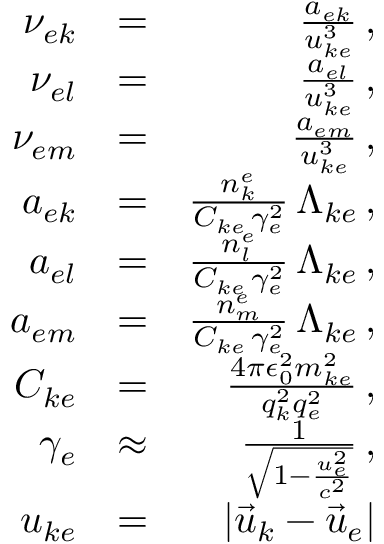Convert formula to latex. <formula><loc_0><loc_0><loc_500><loc_500>\begin{array} { r l r } { \nu _ { e k } } & { = } & { \frac { a _ { e k } } { u _ { k e } ^ { 3 } } \, , } \\ { \nu _ { e l } } & { = } & { \frac { a _ { e l } } { u _ { k e } ^ { 3 } } \, , } \\ { \nu _ { e m } } & { = } & { \frac { a _ { e m } } { u _ { k e } ^ { 3 } } \, , } \\ { a _ { e k } } & { = } & { \frac { n _ { k } ^ { e } } { C _ { k e } \, \gamma _ { e } ^ { 2 } } \, \Lambda _ { k e } \, , } \\ { a _ { e l } } & { = } & { \frac { n _ { l } ^ { e } } { C _ { k e } \, \gamma _ { e } ^ { 2 } } \, \Lambda _ { k e } \, , } \\ { a _ { e m } } & { = } & { \frac { n _ { m } ^ { e } } { C _ { k e } \, \gamma _ { e } ^ { 2 } } \, \Lambda _ { k e } \, , } \\ { C _ { k e } } & { = } & { \frac { 4 \pi \epsilon _ { 0 } ^ { 2 } m _ { k e } ^ { 2 } } { q _ { k } ^ { 2 } q _ { e } ^ { 2 } } \, , } \\ { \gamma _ { e } } & { \approx } & { \frac { 1 } { \sqrt { 1 - \frac { u _ { e } ^ { 2 } } { c ^ { 2 } } } } \, , } \\ { u _ { k e } } & { = } & { \left | \vec { u } _ { k } - \vec { u } _ { e } \right | } \end{array}</formula> 